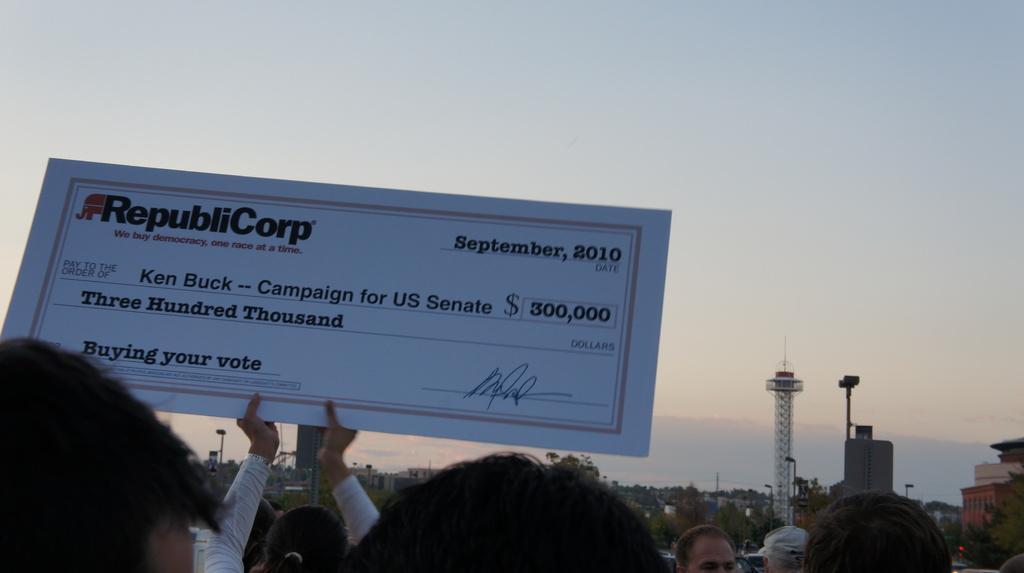In one or two sentences, can you explain what this image depicts? In this image I can see one person is holding the board and something is written on it. I can see few buildings, trees, poles, metal tower and few people. The sky is in blue and white color. 